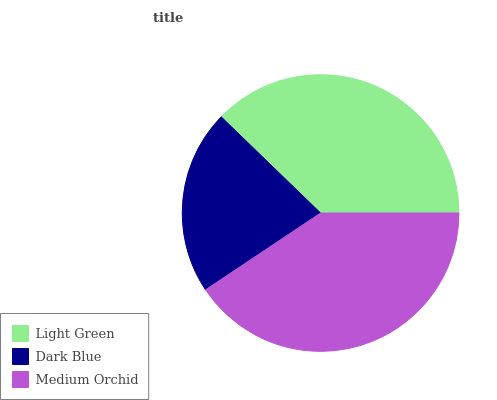Is Dark Blue the minimum?
Answer yes or no. Yes. Is Medium Orchid the maximum?
Answer yes or no. Yes. Is Medium Orchid the minimum?
Answer yes or no. No. Is Dark Blue the maximum?
Answer yes or no. No. Is Medium Orchid greater than Dark Blue?
Answer yes or no. Yes. Is Dark Blue less than Medium Orchid?
Answer yes or no. Yes. Is Dark Blue greater than Medium Orchid?
Answer yes or no. No. Is Medium Orchid less than Dark Blue?
Answer yes or no. No. Is Light Green the high median?
Answer yes or no. Yes. Is Light Green the low median?
Answer yes or no. Yes. Is Medium Orchid the high median?
Answer yes or no. No. Is Dark Blue the low median?
Answer yes or no. No. 